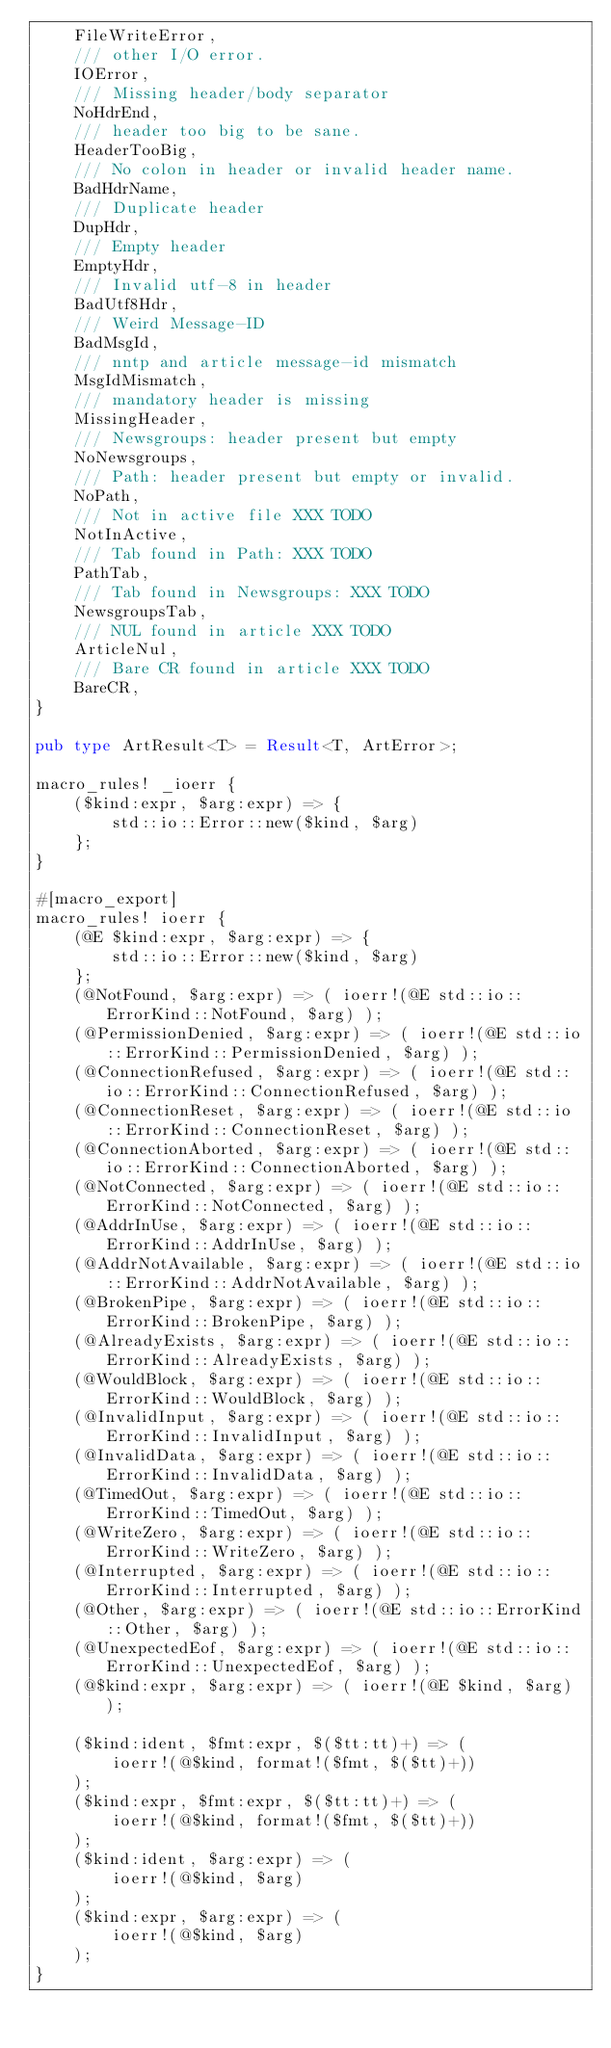Convert code to text. <code><loc_0><loc_0><loc_500><loc_500><_Rust_>    FileWriteError,
    /// other I/O error.
    IOError,
    /// Missing header/body separator
    NoHdrEnd,
    /// header too big to be sane.
    HeaderTooBig,
    /// No colon in header or invalid header name.
    BadHdrName,
    /// Duplicate header
    DupHdr,
    /// Empty header
    EmptyHdr,
    /// Invalid utf-8 in header
    BadUtf8Hdr,
    /// Weird Message-ID
    BadMsgId,
    /// nntp and article message-id mismatch
    MsgIdMismatch,
    /// mandatory header is missing
    MissingHeader,
    /// Newsgroups: header present but empty
    NoNewsgroups,
    /// Path: header present but empty or invalid.
    NoPath,
    /// Not in active file XXX TODO
    NotInActive,
    /// Tab found in Path: XXX TODO
    PathTab,
    /// Tab found in Newsgroups: XXX TODO
    NewsgroupsTab,
    /// NUL found in article XXX TODO
    ArticleNul,
    /// Bare CR found in article XXX TODO
    BareCR,
}

pub type ArtResult<T> = Result<T, ArtError>;

macro_rules! _ioerr {
    ($kind:expr, $arg:expr) => {
        std::io::Error::new($kind, $arg)
    };
}

#[macro_export]
macro_rules! ioerr {
    (@E $kind:expr, $arg:expr) => {
        std::io::Error::new($kind, $arg)
    };
    (@NotFound, $arg:expr) => ( ioerr!(@E std::io::ErrorKind::NotFound, $arg) );
    (@PermissionDenied, $arg:expr) => ( ioerr!(@E std::io::ErrorKind::PermissionDenied, $arg) );
    (@ConnectionRefused, $arg:expr) => ( ioerr!(@E std::io::ErrorKind::ConnectionRefused, $arg) );
    (@ConnectionReset, $arg:expr) => ( ioerr!(@E std::io::ErrorKind::ConnectionReset, $arg) );
    (@ConnectionAborted, $arg:expr) => ( ioerr!(@E std::io::ErrorKind::ConnectionAborted, $arg) );
    (@NotConnected, $arg:expr) => ( ioerr!(@E std::io::ErrorKind::NotConnected, $arg) );
    (@AddrInUse, $arg:expr) => ( ioerr!(@E std::io::ErrorKind::AddrInUse, $arg) );
    (@AddrNotAvailable, $arg:expr) => ( ioerr!(@E std::io::ErrorKind::AddrNotAvailable, $arg) );
    (@BrokenPipe, $arg:expr) => ( ioerr!(@E std::io::ErrorKind::BrokenPipe, $arg) );
    (@AlreadyExists, $arg:expr) => ( ioerr!(@E std::io::ErrorKind::AlreadyExists, $arg) );
    (@WouldBlock, $arg:expr) => ( ioerr!(@E std::io::ErrorKind::WouldBlock, $arg) );
    (@InvalidInput, $arg:expr) => ( ioerr!(@E std::io::ErrorKind::InvalidInput, $arg) );
    (@InvalidData, $arg:expr) => ( ioerr!(@E std::io::ErrorKind::InvalidData, $arg) );
    (@TimedOut, $arg:expr) => ( ioerr!(@E std::io::ErrorKind::TimedOut, $arg) );
    (@WriteZero, $arg:expr) => ( ioerr!(@E std::io::ErrorKind::WriteZero, $arg) );
    (@Interrupted, $arg:expr) => ( ioerr!(@E std::io::ErrorKind::Interrupted, $arg) );
    (@Other, $arg:expr) => ( ioerr!(@E std::io::ErrorKind::Other, $arg) );
    (@UnexpectedEof, $arg:expr) => ( ioerr!(@E std::io::ErrorKind::UnexpectedEof, $arg) );
    (@$kind:expr, $arg:expr) => ( ioerr!(@E $kind, $arg) );

    ($kind:ident, $fmt:expr, $($tt:tt)+) => (
        ioerr!(@$kind, format!($fmt, $($tt)+))
    );
    ($kind:expr, $fmt:expr, $($tt:tt)+) => (
        ioerr!(@$kind, format!($fmt, $($tt)+))
    );
    ($kind:ident, $arg:expr) => (
        ioerr!(@$kind, $arg)
    );
    ($kind:expr, $arg:expr) => (
        ioerr!(@$kind, $arg)
    );
}
</code> 